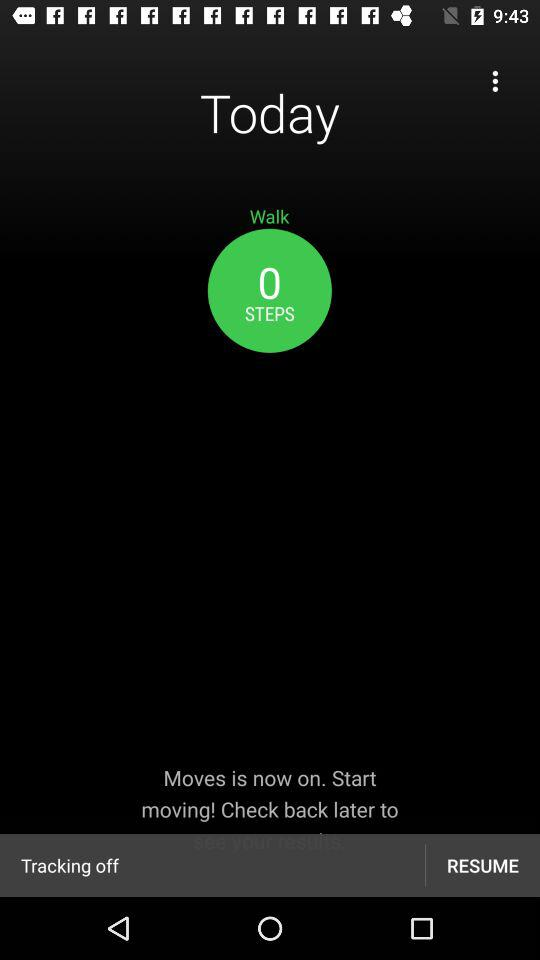How many steps have I taken?
Answer the question using a single word or phrase. 0 